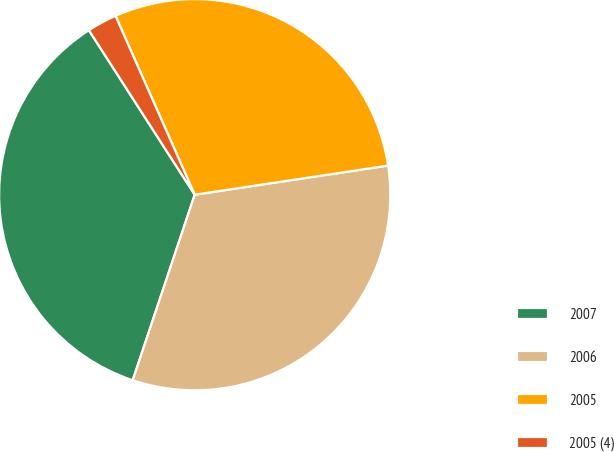<chart> <loc_0><loc_0><loc_500><loc_500><pie_chart><fcel>2007<fcel>2006<fcel>2005<fcel>2005 (4)<nl><fcel>35.77%<fcel>32.51%<fcel>29.25%<fcel>2.46%<nl></chart> 